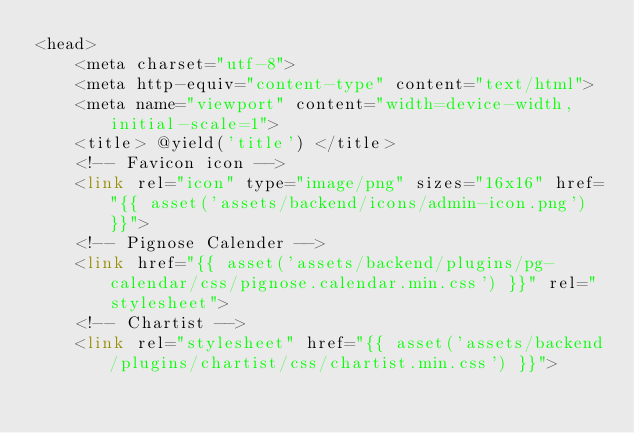<code> <loc_0><loc_0><loc_500><loc_500><_PHP_><head>
    <meta charset="utf-8">
    <meta http-equiv="content-type" content="text/html">
    <meta name="viewport" content="width=device-width,initial-scale=1">
    <title> @yield('title') </title>
    <!-- Favicon icon -->
    <link rel="icon" type="image/png" sizes="16x16" href="{{ asset('assets/backend/icons/admin-icon.png') }}">
    <!-- Pignose Calender -->
    <link href="{{ asset('assets/backend/plugins/pg-calendar/css/pignose.calendar.min.css') }}" rel="stylesheet">
    <!-- Chartist -->
    <link rel="stylesheet" href="{{ asset('assets/backend/plugins/chartist/css/chartist.min.css') }}"></code> 